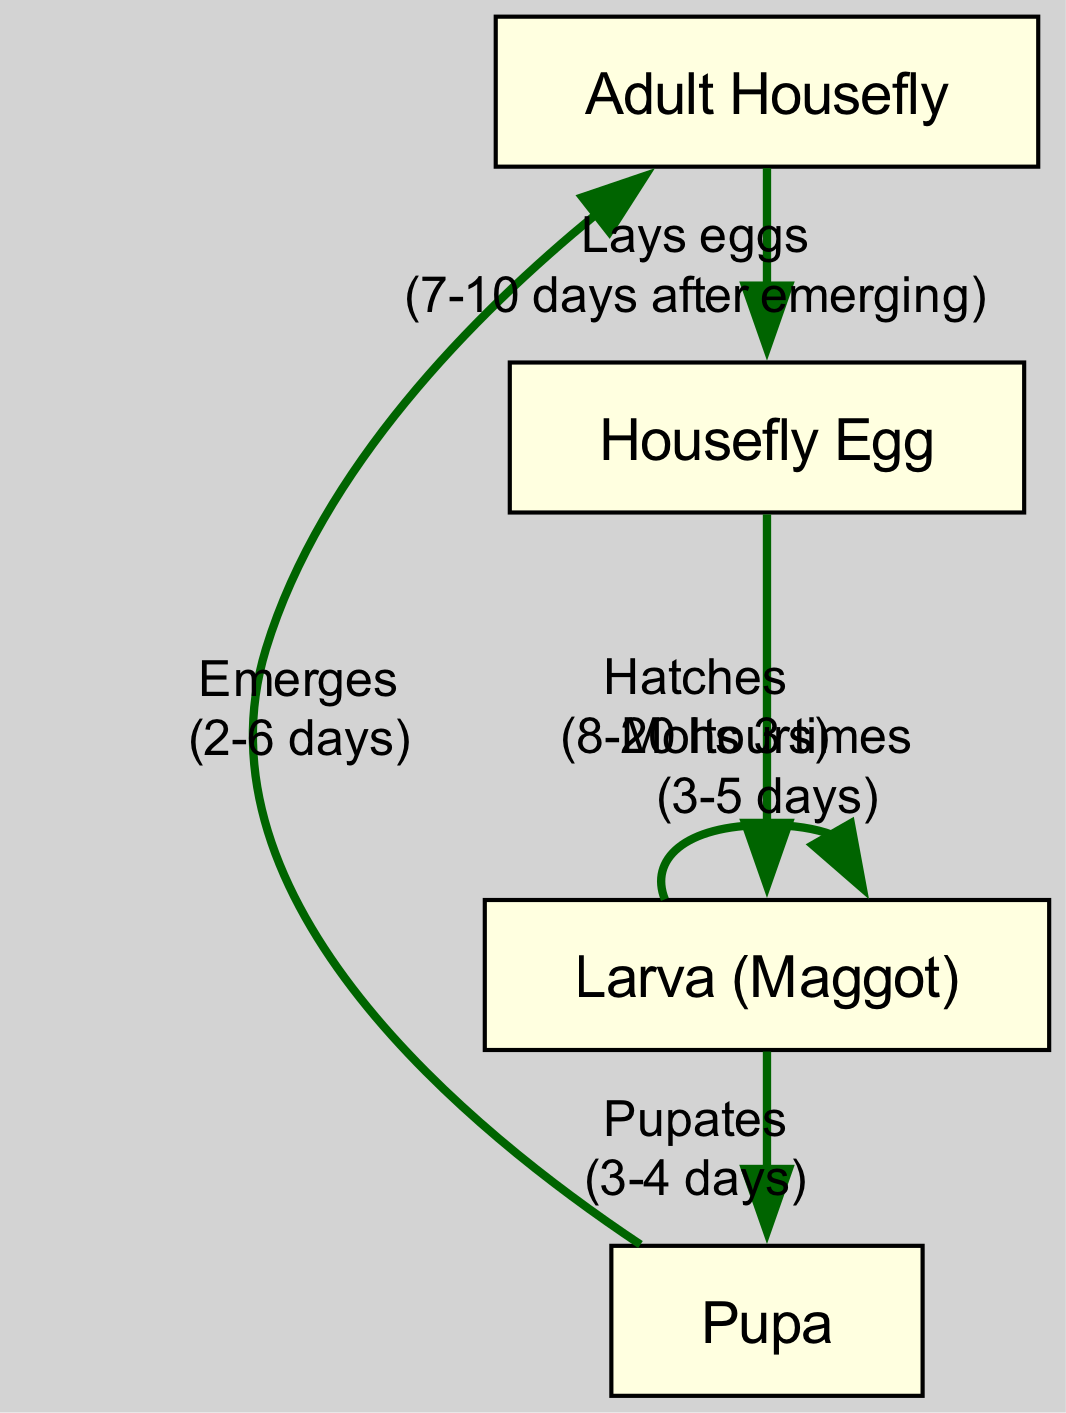What is the first stage in the life cycle of a housefly? The diagram shows the flow starting from the "Housefly Egg" as the first node before any other stages. This indicates that it is the initial stage in the life cycle.
Answer: Housefly Egg How long does it take for the housefly egg to hatch? Referring to the edge from "Housefly Egg" to "Larva (Maggot)", the label indicates the hatching time is between 8 to 20 hours.
Answer: 8-20 hours What action occurs during the transition from larva to pupa? The diagram specifies the action labeled along the edge from "Larva (Maggot)" to "Pupa" as "Pupates", meaning this is the designated action for this transition.
Answer: Pupates How many times does the larva molt? Within the edge from "Larva (Maggot)" to itself, it clearly states that it "Molts 3 times", signifying the number of molts that the larva undergoes.
Answer: 3 times How long does the pupa stage last before emerging as an adult? The label along the edge from "Pupa" to "Adult Housefly" specifies that this stage takes between 2 to 6 days before the pupa emerges as an adult.
Answer: 2-6 days What is the overall duration from egg to adult housefly? To determine this, we sum up the transitions: 8-20 hours for hatching, approximately 3-5 days for larval development, 3-4 days for pupation, and 2-6 days for the emergence as an adult. Totaling these gives a range from approximately 5 to 15 days at minimum, depending on the time intervals taken.
Answer: 5-15 days What is the last action in the life cycle of a housefly? The last edge shown in the diagram transitions from "Adult Housefly" to "Housefly Egg" with the action labeled as "Lays eggs", indicating this is the final action in the cycle.
Answer: Lays eggs When does the adult housefly lay eggs after emerging? The transition from "Adult Housefly" to "Housefly Egg" states that it lays eggs "7-10 days after emerging", marking the interval after which it begins the reproductive stage.
Answer: 7-10 days after emerging Which stage happens after the larva stage? Following the sequence, the stage that comes directly after "Larva (Maggot)" is "Pupa", as indicated by the edge that connects these two stages.
Answer: Pupa 